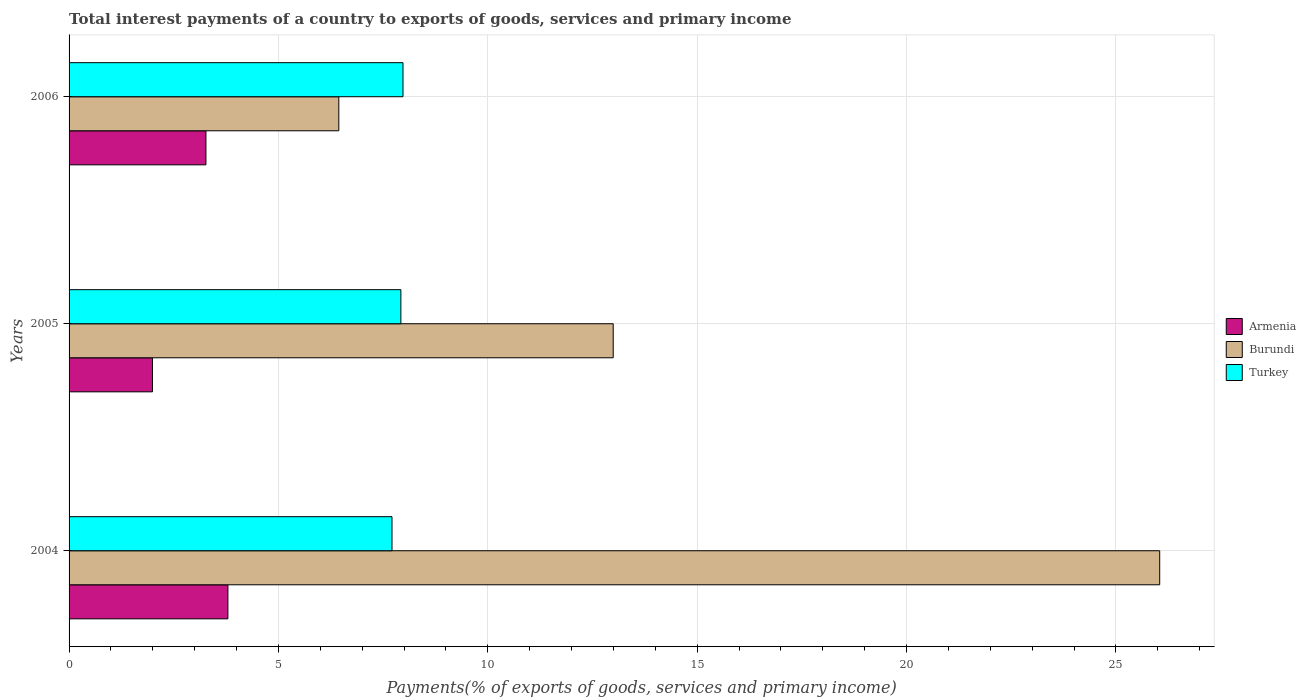How many groups of bars are there?
Make the answer very short. 3. How many bars are there on the 3rd tick from the top?
Offer a very short reply. 3. In how many cases, is the number of bars for a given year not equal to the number of legend labels?
Provide a succinct answer. 0. What is the total interest payments in Armenia in 2006?
Offer a terse response. 3.27. Across all years, what is the maximum total interest payments in Armenia?
Provide a succinct answer. 3.79. Across all years, what is the minimum total interest payments in Turkey?
Provide a short and direct response. 7.71. In which year was the total interest payments in Armenia minimum?
Keep it short and to the point. 2005. What is the total total interest payments in Burundi in the graph?
Offer a terse response. 45.48. What is the difference between the total interest payments in Burundi in 2004 and that in 2005?
Provide a succinct answer. 13.05. What is the difference between the total interest payments in Armenia in 2006 and the total interest payments in Turkey in 2005?
Make the answer very short. -4.66. What is the average total interest payments in Burundi per year?
Offer a very short reply. 15.16. In the year 2005, what is the difference between the total interest payments in Armenia and total interest payments in Turkey?
Give a very brief answer. -5.93. In how many years, is the total interest payments in Armenia greater than 24 %?
Offer a very short reply. 0. What is the ratio of the total interest payments in Turkey in 2004 to that in 2006?
Keep it short and to the point. 0.97. Is the total interest payments in Turkey in 2005 less than that in 2006?
Your response must be concise. Yes. Is the difference between the total interest payments in Armenia in 2004 and 2006 greater than the difference between the total interest payments in Turkey in 2004 and 2006?
Keep it short and to the point. Yes. What is the difference between the highest and the second highest total interest payments in Turkey?
Provide a short and direct response. 0.05. What is the difference between the highest and the lowest total interest payments in Armenia?
Ensure brevity in your answer.  1.8. In how many years, is the total interest payments in Armenia greater than the average total interest payments in Armenia taken over all years?
Your response must be concise. 2. What does the 3rd bar from the top in 2005 represents?
Your response must be concise. Armenia. What does the 2nd bar from the bottom in 2004 represents?
Provide a short and direct response. Burundi. What is the difference between two consecutive major ticks on the X-axis?
Ensure brevity in your answer.  5. Are the values on the major ticks of X-axis written in scientific E-notation?
Provide a succinct answer. No. Does the graph contain any zero values?
Your response must be concise. No. Does the graph contain grids?
Offer a very short reply. Yes. How are the legend labels stacked?
Give a very brief answer. Vertical. What is the title of the graph?
Offer a terse response. Total interest payments of a country to exports of goods, services and primary income. Does "El Salvador" appear as one of the legend labels in the graph?
Offer a terse response. No. What is the label or title of the X-axis?
Your answer should be very brief. Payments(% of exports of goods, services and primary income). What is the label or title of the Y-axis?
Provide a succinct answer. Years. What is the Payments(% of exports of goods, services and primary income) of Armenia in 2004?
Provide a succinct answer. 3.79. What is the Payments(% of exports of goods, services and primary income) of Burundi in 2004?
Provide a short and direct response. 26.05. What is the Payments(% of exports of goods, services and primary income) of Turkey in 2004?
Keep it short and to the point. 7.71. What is the Payments(% of exports of goods, services and primary income) of Armenia in 2005?
Give a very brief answer. 1.99. What is the Payments(% of exports of goods, services and primary income) of Burundi in 2005?
Your response must be concise. 13. What is the Payments(% of exports of goods, services and primary income) in Turkey in 2005?
Keep it short and to the point. 7.92. What is the Payments(% of exports of goods, services and primary income) of Armenia in 2006?
Your answer should be compact. 3.27. What is the Payments(% of exports of goods, services and primary income) of Burundi in 2006?
Your answer should be very brief. 6.44. What is the Payments(% of exports of goods, services and primary income) in Turkey in 2006?
Provide a succinct answer. 7.97. Across all years, what is the maximum Payments(% of exports of goods, services and primary income) of Armenia?
Provide a succinct answer. 3.79. Across all years, what is the maximum Payments(% of exports of goods, services and primary income) of Burundi?
Give a very brief answer. 26.05. Across all years, what is the maximum Payments(% of exports of goods, services and primary income) in Turkey?
Your answer should be very brief. 7.97. Across all years, what is the minimum Payments(% of exports of goods, services and primary income) of Armenia?
Provide a short and direct response. 1.99. Across all years, what is the minimum Payments(% of exports of goods, services and primary income) in Burundi?
Your answer should be compact. 6.44. Across all years, what is the minimum Payments(% of exports of goods, services and primary income) of Turkey?
Keep it short and to the point. 7.71. What is the total Payments(% of exports of goods, services and primary income) of Armenia in the graph?
Make the answer very short. 9.05. What is the total Payments(% of exports of goods, services and primary income) in Burundi in the graph?
Offer a terse response. 45.48. What is the total Payments(% of exports of goods, services and primary income) of Turkey in the graph?
Make the answer very short. 23.61. What is the difference between the Payments(% of exports of goods, services and primary income) in Armenia in 2004 and that in 2005?
Provide a short and direct response. 1.8. What is the difference between the Payments(% of exports of goods, services and primary income) of Burundi in 2004 and that in 2005?
Provide a short and direct response. 13.05. What is the difference between the Payments(% of exports of goods, services and primary income) in Turkey in 2004 and that in 2005?
Give a very brief answer. -0.21. What is the difference between the Payments(% of exports of goods, services and primary income) in Armenia in 2004 and that in 2006?
Your response must be concise. 0.52. What is the difference between the Payments(% of exports of goods, services and primary income) of Burundi in 2004 and that in 2006?
Give a very brief answer. 19.6. What is the difference between the Payments(% of exports of goods, services and primary income) of Turkey in 2004 and that in 2006?
Provide a short and direct response. -0.26. What is the difference between the Payments(% of exports of goods, services and primary income) of Armenia in 2005 and that in 2006?
Offer a very short reply. -1.28. What is the difference between the Payments(% of exports of goods, services and primary income) in Burundi in 2005 and that in 2006?
Offer a terse response. 6.55. What is the difference between the Payments(% of exports of goods, services and primary income) in Turkey in 2005 and that in 2006?
Keep it short and to the point. -0.05. What is the difference between the Payments(% of exports of goods, services and primary income) of Armenia in 2004 and the Payments(% of exports of goods, services and primary income) of Burundi in 2005?
Ensure brevity in your answer.  -9.2. What is the difference between the Payments(% of exports of goods, services and primary income) of Armenia in 2004 and the Payments(% of exports of goods, services and primary income) of Turkey in 2005?
Offer a terse response. -4.13. What is the difference between the Payments(% of exports of goods, services and primary income) in Burundi in 2004 and the Payments(% of exports of goods, services and primary income) in Turkey in 2005?
Make the answer very short. 18.12. What is the difference between the Payments(% of exports of goods, services and primary income) of Armenia in 2004 and the Payments(% of exports of goods, services and primary income) of Burundi in 2006?
Keep it short and to the point. -2.65. What is the difference between the Payments(% of exports of goods, services and primary income) of Armenia in 2004 and the Payments(% of exports of goods, services and primary income) of Turkey in 2006?
Provide a short and direct response. -4.18. What is the difference between the Payments(% of exports of goods, services and primary income) of Burundi in 2004 and the Payments(% of exports of goods, services and primary income) of Turkey in 2006?
Ensure brevity in your answer.  18.07. What is the difference between the Payments(% of exports of goods, services and primary income) in Armenia in 2005 and the Payments(% of exports of goods, services and primary income) in Burundi in 2006?
Make the answer very short. -4.45. What is the difference between the Payments(% of exports of goods, services and primary income) in Armenia in 2005 and the Payments(% of exports of goods, services and primary income) in Turkey in 2006?
Provide a short and direct response. -5.98. What is the difference between the Payments(% of exports of goods, services and primary income) of Burundi in 2005 and the Payments(% of exports of goods, services and primary income) of Turkey in 2006?
Ensure brevity in your answer.  5.02. What is the average Payments(% of exports of goods, services and primary income) of Armenia per year?
Ensure brevity in your answer.  3.02. What is the average Payments(% of exports of goods, services and primary income) in Burundi per year?
Keep it short and to the point. 15.16. What is the average Payments(% of exports of goods, services and primary income) of Turkey per year?
Offer a terse response. 7.87. In the year 2004, what is the difference between the Payments(% of exports of goods, services and primary income) in Armenia and Payments(% of exports of goods, services and primary income) in Burundi?
Offer a very short reply. -22.25. In the year 2004, what is the difference between the Payments(% of exports of goods, services and primary income) of Armenia and Payments(% of exports of goods, services and primary income) of Turkey?
Provide a succinct answer. -3.92. In the year 2004, what is the difference between the Payments(% of exports of goods, services and primary income) in Burundi and Payments(% of exports of goods, services and primary income) in Turkey?
Offer a very short reply. 18.33. In the year 2005, what is the difference between the Payments(% of exports of goods, services and primary income) of Armenia and Payments(% of exports of goods, services and primary income) of Burundi?
Give a very brief answer. -11. In the year 2005, what is the difference between the Payments(% of exports of goods, services and primary income) in Armenia and Payments(% of exports of goods, services and primary income) in Turkey?
Offer a very short reply. -5.93. In the year 2005, what is the difference between the Payments(% of exports of goods, services and primary income) of Burundi and Payments(% of exports of goods, services and primary income) of Turkey?
Ensure brevity in your answer.  5.07. In the year 2006, what is the difference between the Payments(% of exports of goods, services and primary income) in Armenia and Payments(% of exports of goods, services and primary income) in Burundi?
Give a very brief answer. -3.17. In the year 2006, what is the difference between the Payments(% of exports of goods, services and primary income) in Armenia and Payments(% of exports of goods, services and primary income) in Turkey?
Your response must be concise. -4.71. In the year 2006, what is the difference between the Payments(% of exports of goods, services and primary income) of Burundi and Payments(% of exports of goods, services and primary income) of Turkey?
Keep it short and to the point. -1.53. What is the ratio of the Payments(% of exports of goods, services and primary income) of Armenia in 2004 to that in 2005?
Offer a terse response. 1.9. What is the ratio of the Payments(% of exports of goods, services and primary income) of Burundi in 2004 to that in 2005?
Ensure brevity in your answer.  2. What is the ratio of the Payments(% of exports of goods, services and primary income) in Turkey in 2004 to that in 2005?
Provide a short and direct response. 0.97. What is the ratio of the Payments(% of exports of goods, services and primary income) in Armenia in 2004 to that in 2006?
Your answer should be very brief. 1.16. What is the ratio of the Payments(% of exports of goods, services and primary income) in Burundi in 2004 to that in 2006?
Keep it short and to the point. 4.04. What is the ratio of the Payments(% of exports of goods, services and primary income) in Turkey in 2004 to that in 2006?
Your answer should be compact. 0.97. What is the ratio of the Payments(% of exports of goods, services and primary income) in Armenia in 2005 to that in 2006?
Provide a succinct answer. 0.61. What is the ratio of the Payments(% of exports of goods, services and primary income) in Burundi in 2005 to that in 2006?
Provide a succinct answer. 2.02. What is the difference between the highest and the second highest Payments(% of exports of goods, services and primary income) of Armenia?
Provide a succinct answer. 0.52. What is the difference between the highest and the second highest Payments(% of exports of goods, services and primary income) of Burundi?
Provide a short and direct response. 13.05. What is the difference between the highest and the second highest Payments(% of exports of goods, services and primary income) in Turkey?
Ensure brevity in your answer.  0.05. What is the difference between the highest and the lowest Payments(% of exports of goods, services and primary income) of Armenia?
Make the answer very short. 1.8. What is the difference between the highest and the lowest Payments(% of exports of goods, services and primary income) of Burundi?
Make the answer very short. 19.6. What is the difference between the highest and the lowest Payments(% of exports of goods, services and primary income) of Turkey?
Ensure brevity in your answer.  0.26. 